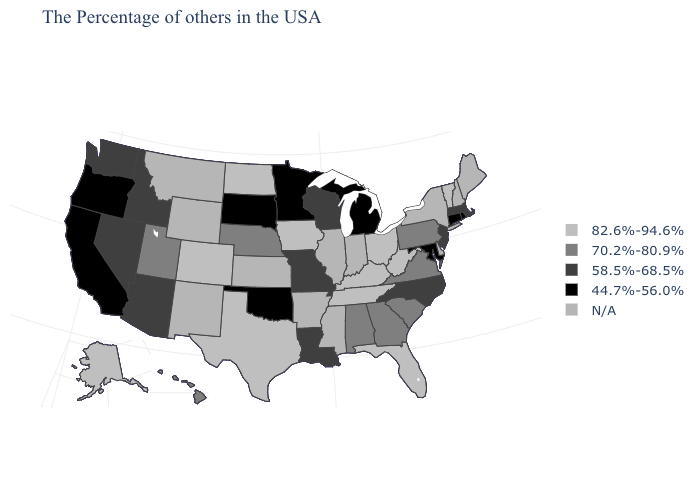What is the value of Missouri?
Be succinct. 58.5%-68.5%. What is the value of Oregon?
Write a very short answer. 44.7%-56.0%. What is the highest value in states that border Iowa?
Quick response, please. 70.2%-80.9%. Name the states that have a value in the range 82.6%-94.6%?
Answer briefly. Vermont, West Virginia, Ohio, Florida, Kentucky, Tennessee, Iowa, Texas, North Dakota, Colorado, Alaska. Does Nebraska have the lowest value in the MidWest?
Write a very short answer. No. Does the map have missing data?
Concise answer only. Yes. What is the lowest value in the West?
Answer briefly. 44.7%-56.0%. Among the states that border Michigan , which have the highest value?
Keep it brief. Ohio. Which states have the lowest value in the USA?
Concise answer only. Rhode Island, Connecticut, Maryland, Michigan, Minnesota, Oklahoma, South Dakota, California, Oregon. Name the states that have a value in the range 82.6%-94.6%?
Short answer required. Vermont, West Virginia, Ohio, Florida, Kentucky, Tennessee, Iowa, Texas, North Dakota, Colorado, Alaska. Among the states that border Washington , does Oregon have the lowest value?
Write a very short answer. Yes. Which states hav the highest value in the West?
Concise answer only. Colorado, Alaska. Is the legend a continuous bar?
Answer briefly. No. What is the lowest value in the South?
Write a very short answer. 44.7%-56.0%. Name the states that have a value in the range 82.6%-94.6%?
Be succinct. Vermont, West Virginia, Ohio, Florida, Kentucky, Tennessee, Iowa, Texas, North Dakota, Colorado, Alaska. 